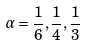Convert formula to latex. <formula><loc_0><loc_0><loc_500><loc_500>\alpha = \frac { 1 } { 6 } , \frac { 1 } { 4 } , \frac { 1 } { 3 }</formula> 